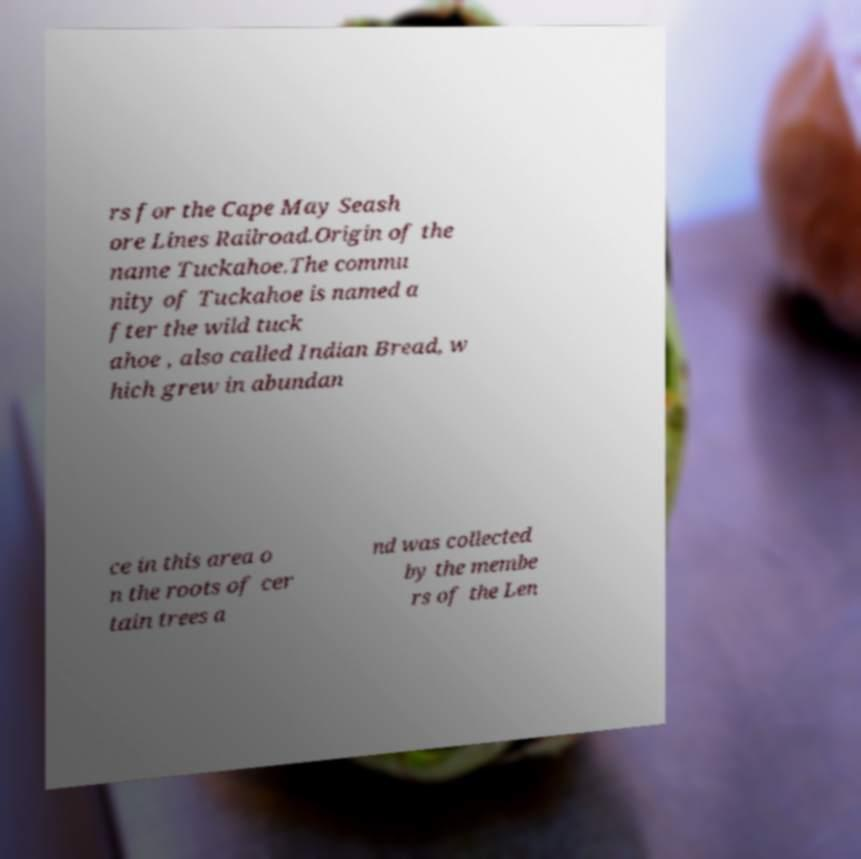Could you extract and type out the text from this image? rs for the Cape May Seash ore Lines Railroad.Origin of the name Tuckahoe.The commu nity of Tuckahoe is named a fter the wild tuck ahoe , also called Indian Bread, w hich grew in abundan ce in this area o n the roots of cer tain trees a nd was collected by the membe rs of the Len 